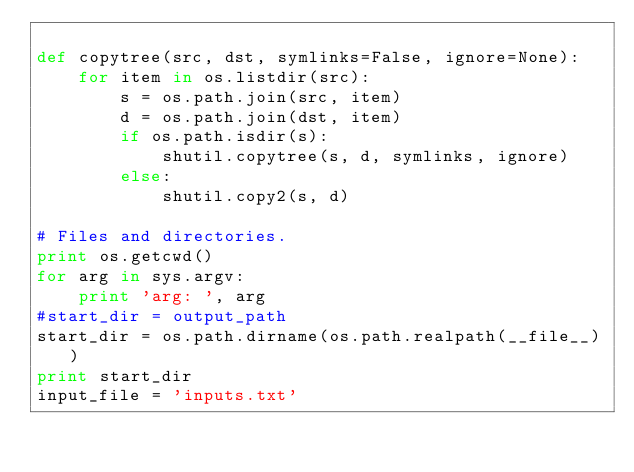Convert code to text. <code><loc_0><loc_0><loc_500><loc_500><_Python_>
def copytree(src, dst, symlinks=False, ignore=None):
    for item in os.listdir(src):
        s = os.path.join(src, item)
        d = os.path.join(dst, item)
        if os.path.isdir(s):
            shutil.copytree(s, d, symlinks, ignore)
        else:
            shutil.copy2(s, d)

# Files and directories.
print os.getcwd()
for arg in sys.argv:
    print 'arg: ', arg
#start_dir = output_path
start_dir = os.path.dirname(os.path.realpath(__file__))
print start_dir
input_file = 'inputs.txt'</code> 